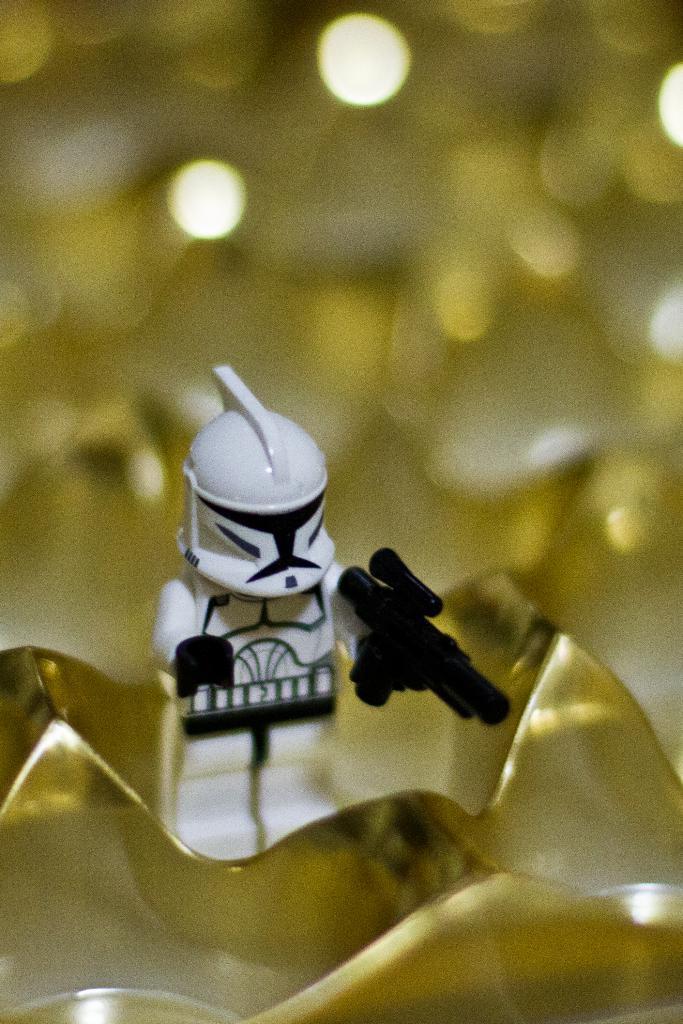Could you give a brief overview of what you see in this image? In this picture we can see you on the platform. In the background of the image it is blurry. 